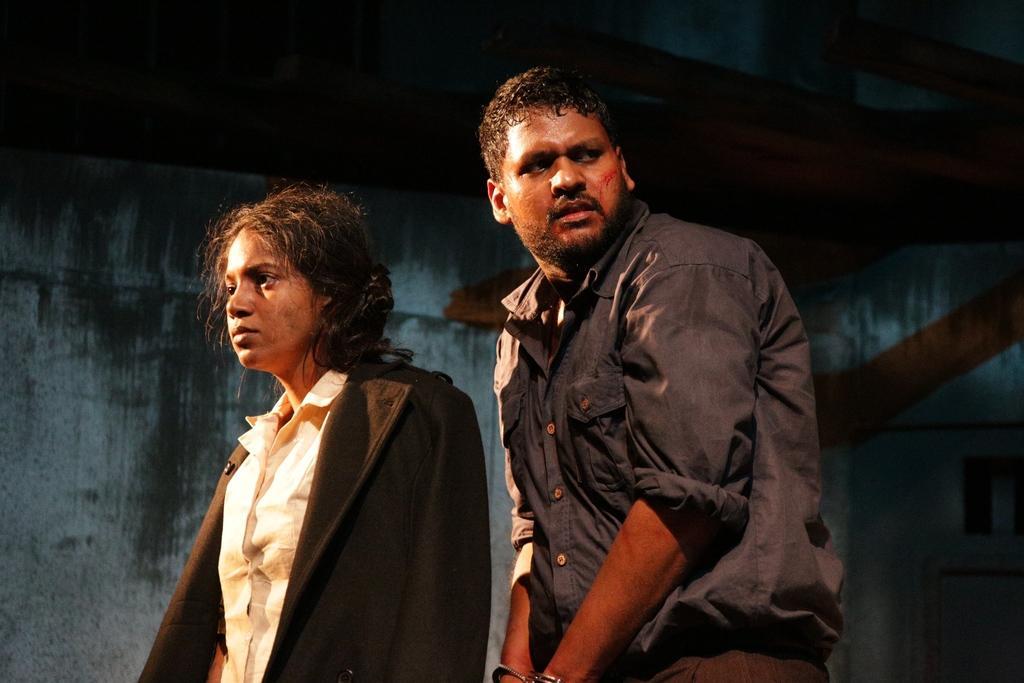Can you describe this image briefly? On the left side a woman is there, she wore black color coat. Beside her a man is there, he wore shirt. 